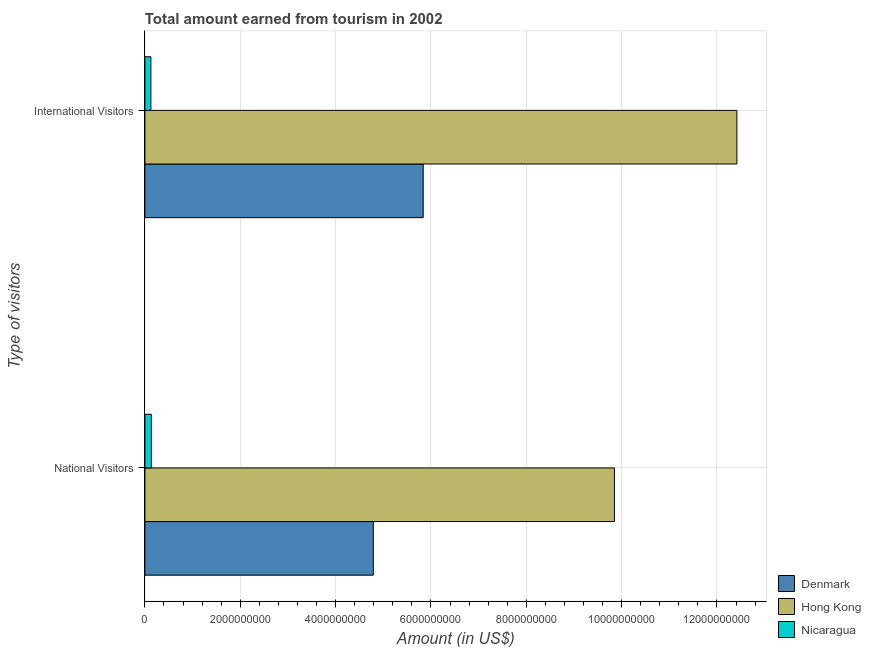How many different coloured bars are there?
Make the answer very short. 3. How many bars are there on the 2nd tick from the top?
Offer a terse response. 3. What is the label of the 2nd group of bars from the top?
Ensure brevity in your answer.  National Visitors. What is the amount earned from national visitors in Hong Kong?
Give a very brief answer. 9.85e+09. Across all countries, what is the maximum amount earned from national visitors?
Your answer should be very brief. 9.85e+09. Across all countries, what is the minimum amount earned from international visitors?
Your answer should be very brief. 1.25e+08. In which country was the amount earned from international visitors maximum?
Ensure brevity in your answer.  Hong Kong. In which country was the amount earned from international visitors minimum?
Your response must be concise. Nicaragua. What is the total amount earned from national visitors in the graph?
Make the answer very short. 1.48e+1. What is the difference between the amount earned from national visitors in Nicaragua and that in Denmark?
Give a very brief answer. -4.66e+09. What is the difference between the amount earned from international visitors in Hong Kong and the amount earned from national visitors in Nicaragua?
Offer a terse response. 1.23e+1. What is the average amount earned from international visitors per country?
Offer a terse response. 6.13e+09. What is the difference between the amount earned from national visitors and amount earned from international visitors in Denmark?
Ensure brevity in your answer.  -1.05e+09. In how many countries, is the amount earned from national visitors greater than 12000000000 US$?
Your answer should be compact. 0. What is the ratio of the amount earned from national visitors in Hong Kong to that in Nicaragua?
Make the answer very short. 72.96. What does the 2nd bar from the top in National Visitors represents?
Offer a very short reply. Hong Kong. What does the 2nd bar from the bottom in National Visitors represents?
Keep it short and to the point. Hong Kong. How many bars are there?
Your answer should be very brief. 6. How many countries are there in the graph?
Offer a terse response. 3. Does the graph contain grids?
Ensure brevity in your answer.  Yes. Where does the legend appear in the graph?
Keep it short and to the point. Bottom right. What is the title of the graph?
Ensure brevity in your answer.  Total amount earned from tourism in 2002. What is the label or title of the Y-axis?
Offer a terse response. Type of visitors. What is the Amount (in US$) in Denmark in National Visitors?
Your answer should be compact. 4.79e+09. What is the Amount (in US$) of Hong Kong in National Visitors?
Your response must be concise. 9.85e+09. What is the Amount (in US$) in Nicaragua in National Visitors?
Give a very brief answer. 1.35e+08. What is the Amount (in US$) of Denmark in International Visitors?
Offer a terse response. 5.84e+09. What is the Amount (in US$) of Hong Kong in International Visitors?
Provide a short and direct response. 1.24e+1. What is the Amount (in US$) in Nicaragua in International Visitors?
Offer a very short reply. 1.25e+08. Across all Type of visitors, what is the maximum Amount (in US$) in Denmark?
Provide a succinct answer. 5.84e+09. Across all Type of visitors, what is the maximum Amount (in US$) of Hong Kong?
Give a very brief answer. 1.24e+1. Across all Type of visitors, what is the maximum Amount (in US$) in Nicaragua?
Your answer should be very brief. 1.35e+08. Across all Type of visitors, what is the minimum Amount (in US$) of Denmark?
Your answer should be very brief. 4.79e+09. Across all Type of visitors, what is the minimum Amount (in US$) in Hong Kong?
Your response must be concise. 9.85e+09. Across all Type of visitors, what is the minimum Amount (in US$) of Nicaragua?
Ensure brevity in your answer.  1.25e+08. What is the total Amount (in US$) in Denmark in the graph?
Give a very brief answer. 1.06e+1. What is the total Amount (in US$) of Hong Kong in the graph?
Your response must be concise. 2.23e+1. What is the total Amount (in US$) in Nicaragua in the graph?
Your answer should be very brief. 2.60e+08. What is the difference between the Amount (in US$) of Denmark in National Visitors and that in International Visitors?
Offer a very short reply. -1.05e+09. What is the difference between the Amount (in US$) of Hong Kong in National Visitors and that in International Visitors?
Keep it short and to the point. -2.57e+09. What is the difference between the Amount (in US$) of Nicaragua in National Visitors and that in International Visitors?
Provide a succinct answer. 1.00e+07. What is the difference between the Amount (in US$) in Denmark in National Visitors and the Amount (in US$) in Hong Kong in International Visitors?
Provide a succinct answer. -7.63e+09. What is the difference between the Amount (in US$) of Denmark in National Visitors and the Amount (in US$) of Nicaragua in International Visitors?
Your answer should be very brief. 4.67e+09. What is the difference between the Amount (in US$) in Hong Kong in National Visitors and the Amount (in US$) in Nicaragua in International Visitors?
Offer a very short reply. 9.72e+09. What is the average Amount (in US$) in Denmark per Type of visitors?
Your answer should be very brief. 5.31e+09. What is the average Amount (in US$) in Hong Kong per Type of visitors?
Provide a short and direct response. 1.11e+1. What is the average Amount (in US$) in Nicaragua per Type of visitors?
Make the answer very short. 1.30e+08. What is the difference between the Amount (in US$) of Denmark and Amount (in US$) of Hong Kong in National Visitors?
Ensure brevity in your answer.  -5.06e+09. What is the difference between the Amount (in US$) in Denmark and Amount (in US$) in Nicaragua in National Visitors?
Offer a very short reply. 4.66e+09. What is the difference between the Amount (in US$) of Hong Kong and Amount (in US$) of Nicaragua in National Visitors?
Ensure brevity in your answer.  9.71e+09. What is the difference between the Amount (in US$) of Denmark and Amount (in US$) of Hong Kong in International Visitors?
Make the answer very short. -6.58e+09. What is the difference between the Amount (in US$) in Denmark and Amount (in US$) in Nicaragua in International Visitors?
Offer a very short reply. 5.71e+09. What is the difference between the Amount (in US$) of Hong Kong and Amount (in US$) of Nicaragua in International Visitors?
Keep it short and to the point. 1.23e+1. What is the ratio of the Amount (in US$) in Denmark in National Visitors to that in International Visitors?
Your answer should be compact. 0.82. What is the ratio of the Amount (in US$) in Hong Kong in National Visitors to that in International Visitors?
Offer a very short reply. 0.79. What is the difference between the highest and the second highest Amount (in US$) in Denmark?
Ensure brevity in your answer.  1.05e+09. What is the difference between the highest and the second highest Amount (in US$) of Hong Kong?
Your response must be concise. 2.57e+09. What is the difference between the highest and the second highest Amount (in US$) in Nicaragua?
Your answer should be very brief. 1.00e+07. What is the difference between the highest and the lowest Amount (in US$) of Denmark?
Give a very brief answer. 1.05e+09. What is the difference between the highest and the lowest Amount (in US$) in Hong Kong?
Provide a short and direct response. 2.57e+09. 